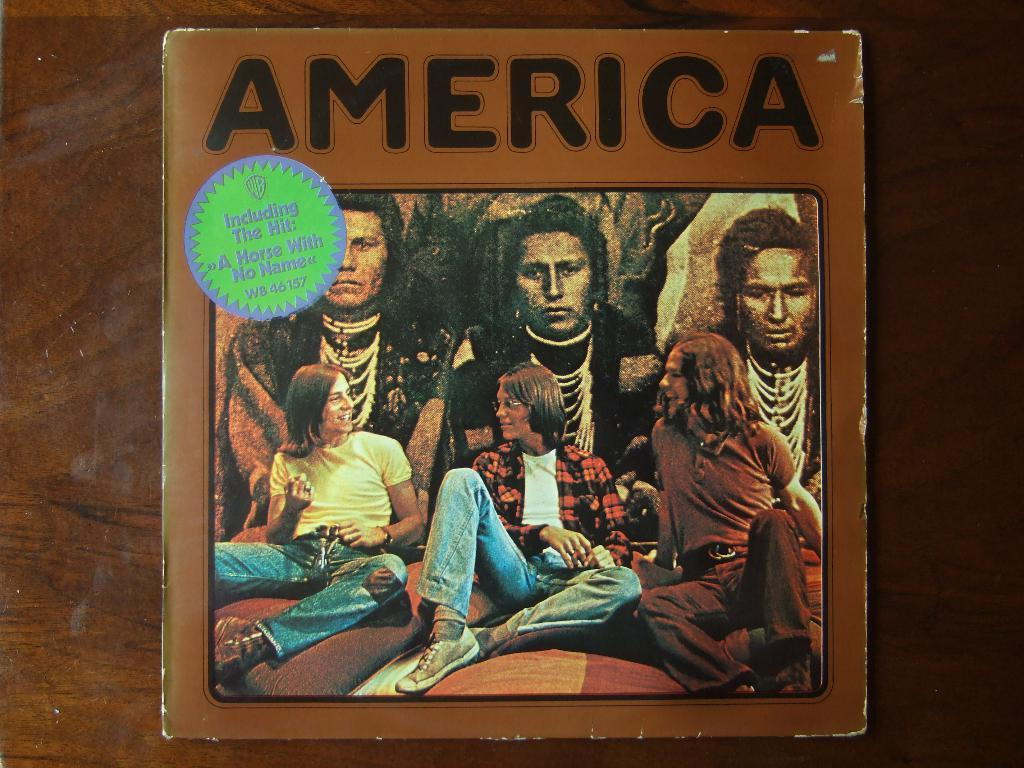Provide a one-sentence caption for the provided image. an older album with the Group America and band on it. 